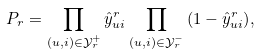<formula> <loc_0><loc_0><loc_500><loc_500>P _ { r } = \prod _ { ( u , i ) \in { \mathcal { Y } _ { r } ^ { + } } } { \hat { y } _ { u i } ^ { r } } \prod _ { ( u , i ) \in { \mathcal { Y } _ { r } ^ { - } } } { { ( 1 - \hat { y } _ { u i } ^ { r } ) } } ,</formula> 